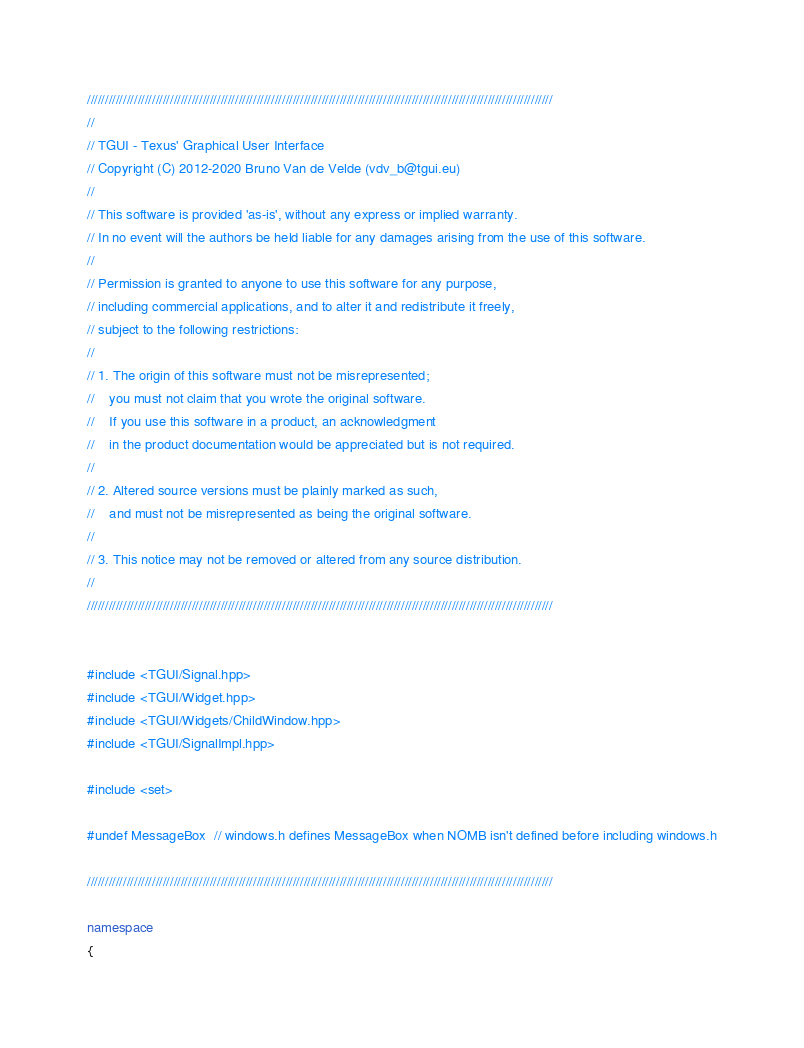<code> <loc_0><loc_0><loc_500><loc_500><_C++_>/////////////////////////////////////////////////////////////////////////////////////////////////////////////////////////////////
//
// TGUI - Texus' Graphical User Interface
// Copyright (C) 2012-2020 Bruno Van de Velde (vdv_b@tgui.eu)
//
// This software is provided 'as-is', without any express or implied warranty.
// In no event will the authors be held liable for any damages arising from the use of this software.
//
// Permission is granted to anyone to use this software for any purpose,
// including commercial applications, and to alter it and redistribute it freely,
// subject to the following restrictions:
//
// 1. The origin of this software must not be misrepresented;
//    you must not claim that you wrote the original software.
//    If you use this software in a product, an acknowledgment
//    in the product documentation would be appreciated but is not required.
//
// 2. Altered source versions must be plainly marked as such,
//    and must not be misrepresented as being the original software.
//
// 3. This notice may not be removed or altered from any source distribution.
//
/////////////////////////////////////////////////////////////////////////////////////////////////////////////////////////////////


#include <TGUI/Signal.hpp>
#include <TGUI/Widget.hpp>
#include <TGUI/Widgets/ChildWindow.hpp>
#include <TGUI/SignalImpl.hpp>

#include <set>

#undef MessageBox  // windows.h defines MessageBox when NOMB isn't defined before including windows.h

/////////////////////////////////////////////////////////////////////////////////////////////////////////////////////////////////

namespace
{</code> 